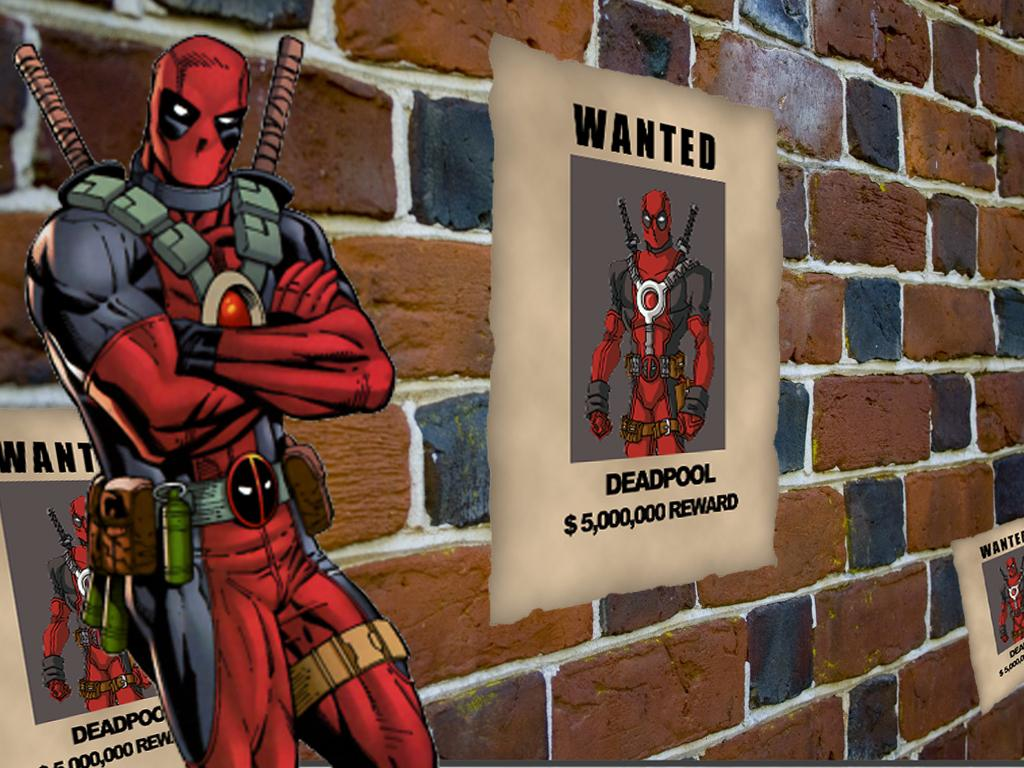<image>
Relay a brief, clear account of the picture shown. A Deadpool wanted advertisement offering a $5,000,000 reward. 